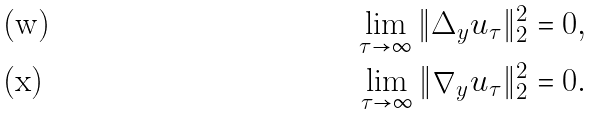Convert formula to latex. <formula><loc_0><loc_0><loc_500><loc_500>\lim _ { \tau \to \infty } \| \Delta _ { y } u _ { \tau } \| ^ { 2 } _ { 2 } = 0 , \\ \lim _ { \tau \to \infty } \| \nabla _ { y } u _ { \tau } \| ^ { 2 } _ { 2 } = 0 .</formula> 